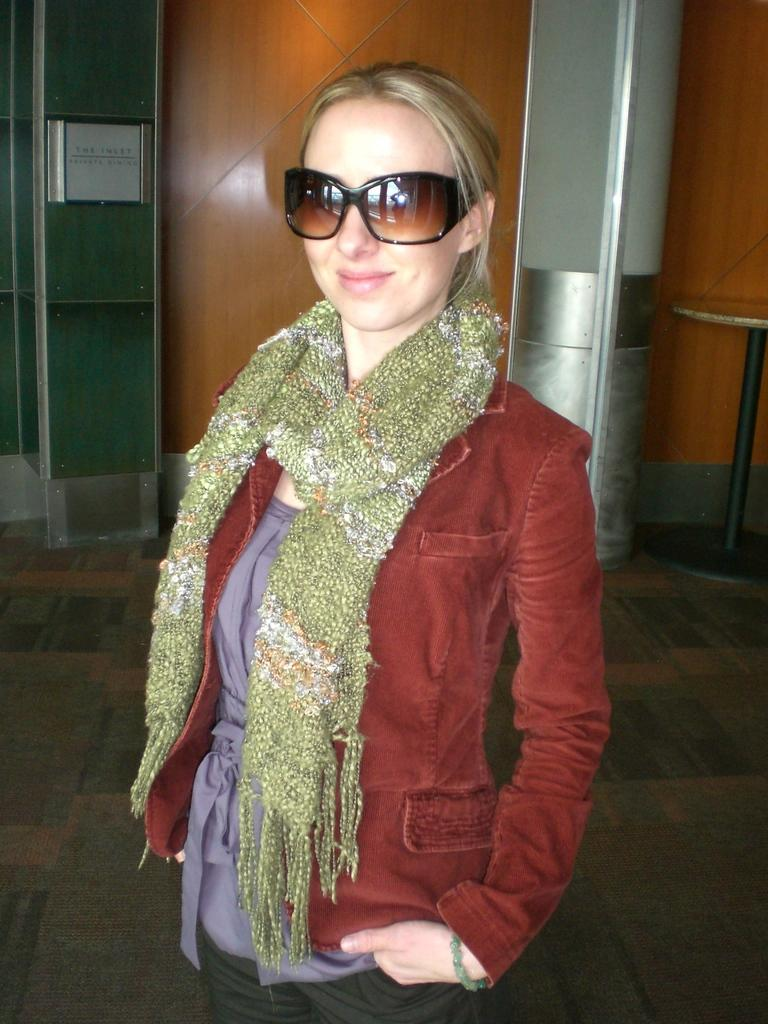What is the main subject of the picture? The main subject of the picture is a woman. What is the woman doing in the picture? The woman is standing in the picture. What is the woman's facial expression in the picture? The woman is smiling in the picture. What type of canvas is the woman painting in the image? There is no canvas or painting activity present in the image; the woman is simply standing and smiling. 